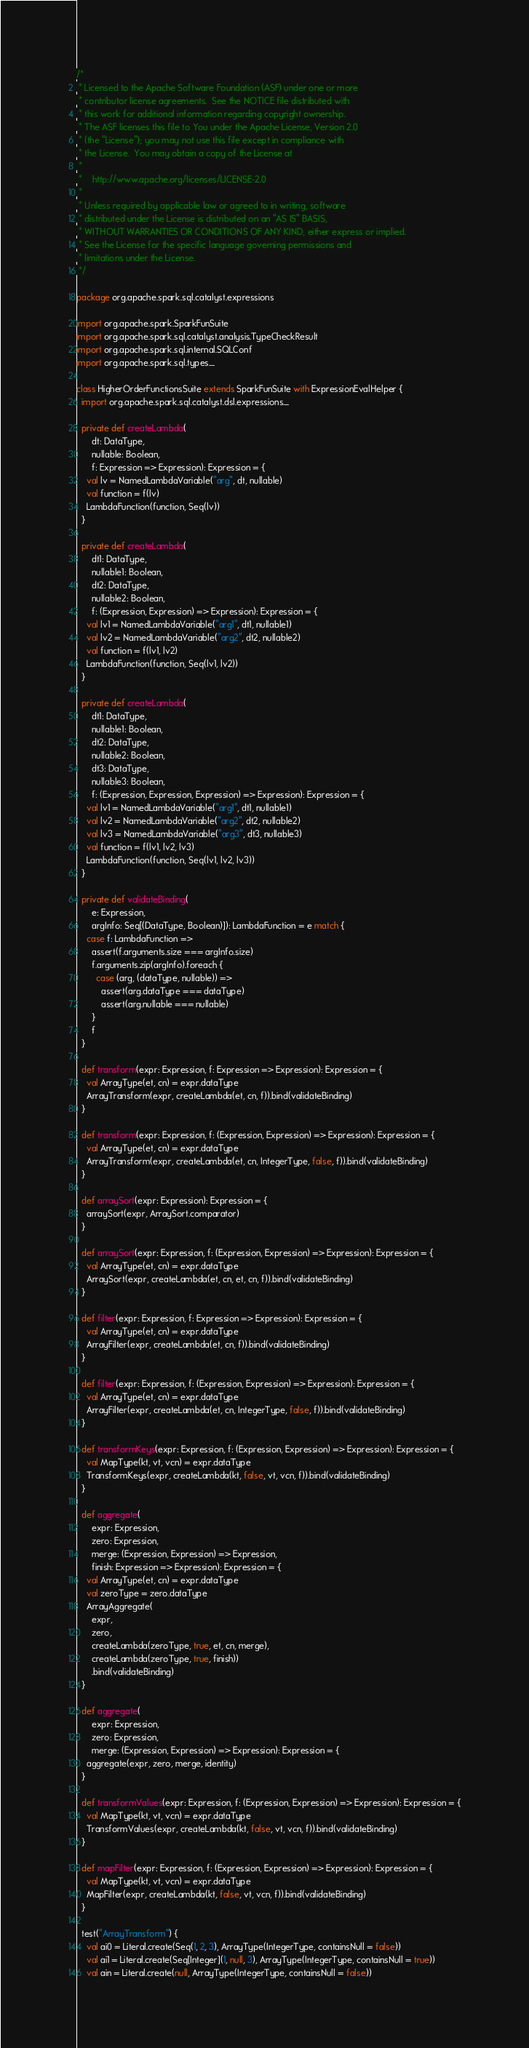<code> <loc_0><loc_0><loc_500><loc_500><_Scala_>/*
 * Licensed to the Apache Software Foundation (ASF) under one or more
 * contributor license agreements.  See the NOTICE file distributed with
 * this work for additional information regarding copyright ownership.
 * The ASF licenses this file to You under the Apache License, Version 2.0
 * (the "License"); you may not use this file except in compliance with
 * the License.  You may obtain a copy of the License at
 *
 *    http://www.apache.org/licenses/LICENSE-2.0
 *
 * Unless required by applicable law or agreed to in writing, software
 * distributed under the License is distributed on an "AS IS" BASIS,
 * WITHOUT WARRANTIES OR CONDITIONS OF ANY KIND, either express or implied.
 * See the License for the specific language governing permissions and
 * limitations under the License.
 */

package org.apache.spark.sql.catalyst.expressions

import org.apache.spark.SparkFunSuite
import org.apache.spark.sql.catalyst.analysis.TypeCheckResult
import org.apache.spark.sql.internal.SQLConf
import org.apache.spark.sql.types._

class HigherOrderFunctionsSuite extends SparkFunSuite with ExpressionEvalHelper {
  import org.apache.spark.sql.catalyst.dsl.expressions._

  private def createLambda(
      dt: DataType,
      nullable: Boolean,
      f: Expression => Expression): Expression = {
    val lv = NamedLambdaVariable("arg", dt, nullable)
    val function = f(lv)
    LambdaFunction(function, Seq(lv))
  }

  private def createLambda(
      dt1: DataType,
      nullable1: Boolean,
      dt2: DataType,
      nullable2: Boolean,
      f: (Expression, Expression) => Expression): Expression = {
    val lv1 = NamedLambdaVariable("arg1", dt1, nullable1)
    val lv2 = NamedLambdaVariable("arg2", dt2, nullable2)
    val function = f(lv1, lv2)
    LambdaFunction(function, Seq(lv1, lv2))
  }

  private def createLambda(
      dt1: DataType,
      nullable1: Boolean,
      dt2: DataType,
      nullable2: Boolean,
      dt3: DataType,
      nullable3: Boolean,
      f: (Expression, Expression, Expression) => Expression): Expression = {
    val lv1 = NamedLambdaVariable("arg1", dt1, nullable1)
    val lv2 = NamedLambdaVariable("arg2", dt2, nullable2)
    val lv3 = NamedLambdaVariable("arg3", dt3, nullable3)
    val function = f(lv1, lv2, lv3)
    LambdaFunction(function, Seq(lv1, lv2, lv3))
  }

  private def validateBinding(
      e: Expression,
      argInfo: Seq[(DataType, Boolean)]): LambdaFunction = e match {
    case f: LambdaFunction =>
      assert(f.arguments.size === argInfo.size)
      f.arguments.zip(argInfo).foreach {
        case (arg, (dataType, nullable)) =>
          assert(arg.dataType === dataType)
          assert(arg.nullable === nullable)
      }
      f
  }

  def transform(expr: Expression, f: Expression => Expression): Expression = {
    val ArrayType(et, cn) = expr.dataType
    ArrayTransform(expr, createLambda(et, cn, f)).bind(validateBinding)
  }

  def transform(expr: Expression, f: (Expression, Expression) => Expression): Expression = {
    val ArrayType(et, cn) = expr.dataType
    ArrayTransform(expr, createLambda(et, cn, IntegerType, false, f)).bind(validateBinding)
  }

  def arraySort(expr: Expression): Expression = {
    arraySort(expr, ArraySort.comparator)
  }

  def arraySort(expr: Expression, f: (Expression, Expression) => Expression): Expression = {
    val ArrayType(et, cn) = expr.dataType
    ArraySort(expr, createLambda(et, cn, et, cn, f)).bind(validateBinding)
  }

  def filter(expr: Expression, f: Expression => Expression): Expression = {
    val ArrayType(et, cn) = expr.dataType
    ArrayFilter(expr, createLambda(et, cn, f)).bind(validateBinding)
  }

  def filter(expr: Expression, f: (Expression, Expression) => Expression): Expression = {
    val ArrayType(et, cn) = expr.dataType
    ArrayFilter(expr, createLambda(et, cn, IntegerType, false, f)).bind(validateBinding)
  }

  def transformKeys(expr: Expression, f: (Expression, Expression) => Expression): Expression = {
    val MapType(kt, vt, vcn) = expr.dataType
    TransformKeys(expr, createLambda(kt, false, vt, vcn, f)).bind(validateBinding)
  }

  def aggregate(
      expr: Expression,
      zero: Expression,
      merge: (Expression, Expression) => Expression,
      finish: Expression => Expression): Expression = {
    val ArrayType(et, cn) = expr.dataType
    val zeroType = zero.dataType
    ArrayAggregate(
      expr,
      zero,
      createLambda(zeroType, true, et, cn, merge),
      createLambda(zeroType, true, finish))
      .bind(validateBinding)
  }

  def aggregate(
      expr: Expression,
      zero: Expression,
      merge: (Expression, Expression) => Expression): Expression = {
    aggregate(expr, zero, merge, identity)
  }

  def transformValues(expr: Expression, f: (Expression, Expression) => Expression): Expression = {
    val MapType(kt, vt, vcn) = expr.dataType
    TransformValues(expr, createLambda(kt, false, vt, vcn, f)).bind(validateBinding)
  }

  def mapFilter(expr: Expression, f: (Expression, Expression) => Expression): Expression = {
    val MapType(kt, vt, vcn) = expr.dataType
    MapFilter(expr, createLambda(kt, false, vt, vcn, f)).bind(validateBinding)
  }

  test("ArrayTransform") {
    val ai0 = Literal.create(Seq(1, 2, 3), ArrayType(IntegerType, containsNull = false))
    val ai1 = Literal.create(Seq[Integer](1, null, 3), ArrayType(IntegerType, containsNull = true))
    val ain = Literal.create(null, ArrayType(IntegerType, containsNull = false))
</code> 